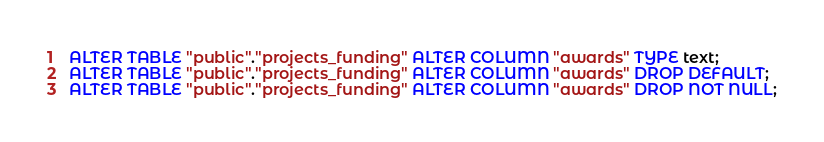Convert code to text. <code><loc_0><loc_0><loc_500><loc_500><_SQL_>ALTER TABLE "public"."projects_funding" ALTER COLUMN "awards" TYPE text;
ALTER TABLE "public"."projects_funding" ALTER COLUMN "awards" DROP DEFAULT;
ALTER TABLE "public"."projects_funding" ALTER COLUMN "awards" DROP NOT NULL;
</code> 